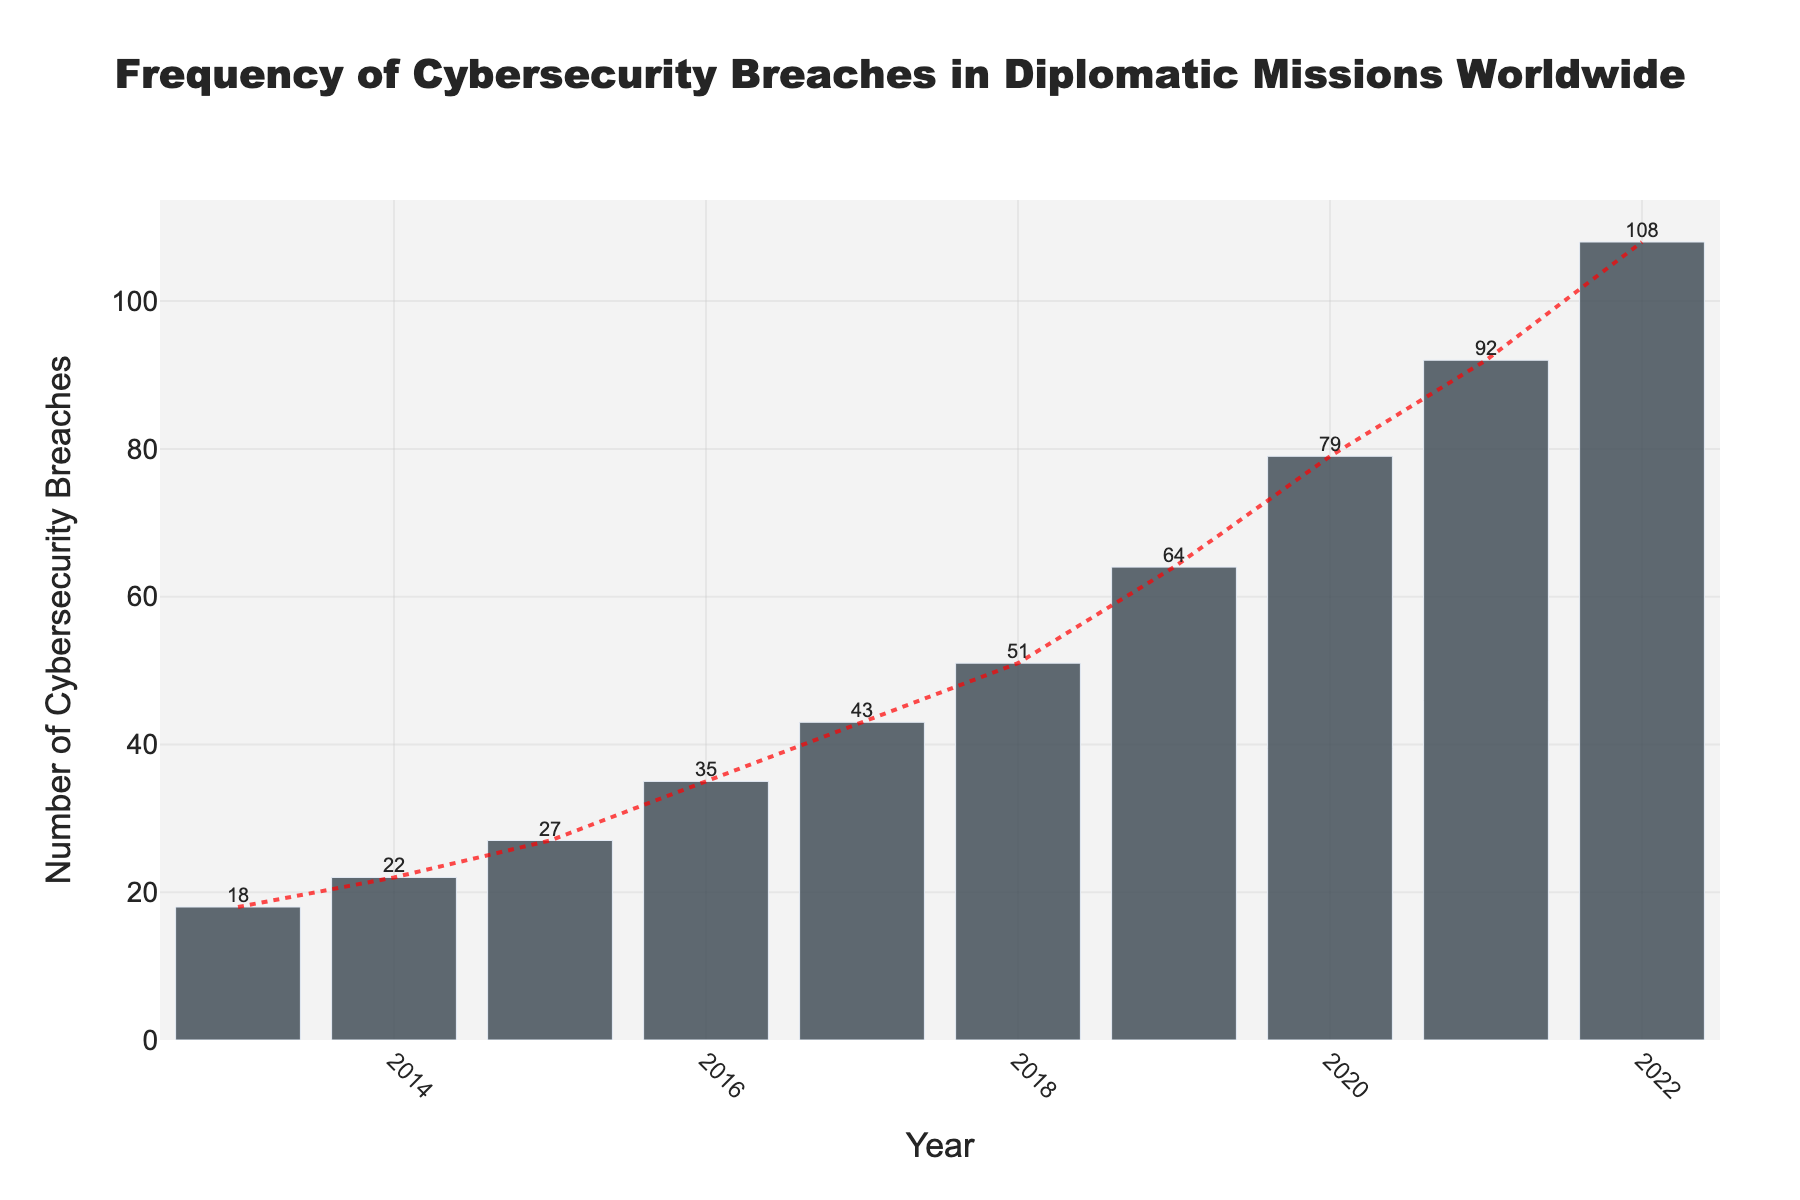How many cybersecurity breaches were reported in the year with the highest frequency? The highest bar corresponds to the year 2022, which has 108 breaches labelled at the top.
Answer: 108 By how many breaches did the number of cybersecurity breaches increase from 2013 to 2022? Subtract the number of breaches in 2013 (18) from those in 2022 (108). 108 - 18 = 90
Answer: 90 Which year showed the largest increase in the number of cybersecurity breaches compared to the previous year? Calculate the differences between consecutive years: 
2014 - 2013: 22 - 18 = 4
2015 - 2014: 27 - 22 = 5
2016 - 2015: 35 - 27 = 8
2017 - 2016: 43 - 35 = 8
2018 - 2017: 51 - 43 = 8
2019 - 2018: 64 - 51 = 13
2020 - 2019: 79 - 64 = 15
2021 - 2020: 92 - 79 = 13
2022 - 2021: 108 - 92 = 16
The largest increase is 16 from 2021 to 2022.
Answer: 2022 Which year had fewer cybersecurity breaches, 2016 or 2018, and by how many? Compare the breaches in 2016 (35) and 2018 (51). Subtract 35 from 51. 51 - 35 = 16
Answer: 2016, by 16 What is the average number of cybersecurity breaches per year over the period shown? Calculate the sum: 18 + 22 + 27 + 35 + 43 + 51 + 64 + 79 + 92 + 108 = 539. Divide by the number of years (10). 539 / 10 = 53.9
Answer: 53.9 What trend can be observed in the number of cybersecurity breaches over the years? The red line representing the trend shows a steady increase in the number of cybersecurity breaches each year.
Answer: Steady increase Which two consecutive years saw the smallest increase in cybersecurity breaches, and what was the increase? Calculate the differences between consecutive years: 
2014 - 2013: 22 - 18 = 4
2015 - 2014: 27 - 22 = 5
2016 - 2015: 35 - 27 = 8
2017 - 2016: 43 - 35 = 8
2018 - 2017: 51 - 43 = 8
2019 - 2018: 64 - 51 = 13
2020 - 2019: 79 - 64 = 15
2021 - 2020: 92 - 79 = 13
2022 - 2021: 108 - 92 = 16
The smallest increase is 4 from 2013 to 2014.
Answer: 2013-2014, 4 